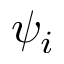<formula> <loc_0><loc_0><loc_500><loc_500>\psi _ { i }</formula> 